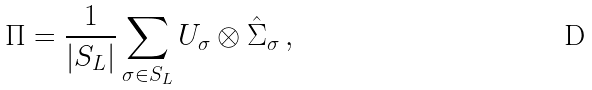Convert formula to latex. <formula><loc_0><loc_0><loc_500><loc_500>\Pi = \frac { 1 } { | S _ { L } | } \sum _ { \sigma \in S _ { L } } U _ { \sigma } \otimes \hat { \Sigma } _ { \sigma } \, ,</formula> 